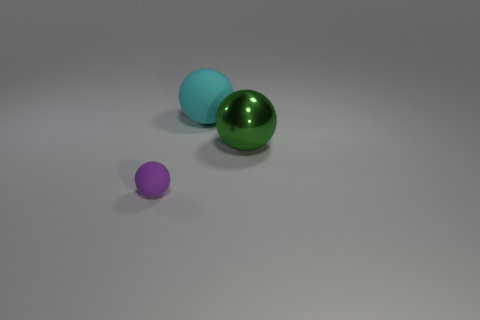Add 2 cyan balls. How many objects exist? 5 Subtract all big green metallic spheres. Subtract all small gray rubber cylinders. How many objects are left? 2 Add 3 big metallic spheres. How many big metallic spheres are left? 4 Add 3 matte balls. How many matte balls exist? 5 Subtract 0 cyan cylinders. How many objects are left? 3 